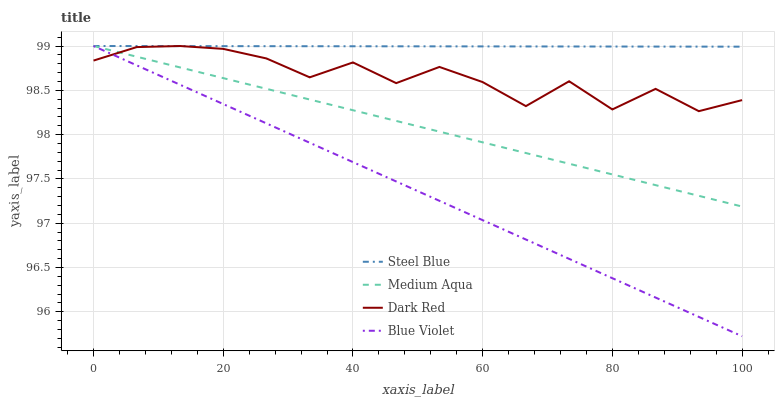Does Medium Aqua have the minimum area under the curve?
Answer yes or no. No. Does Medium Aqua have the maximum area under the curve?
Answer yes or no. No. Is Medium Aqua the smoothest?
Answer yes or no. No. Is Medium Aqua the roughest?
Answer yes or no. No. Does Medium Aqua have the lowest value?
Answer yes or no. No. 